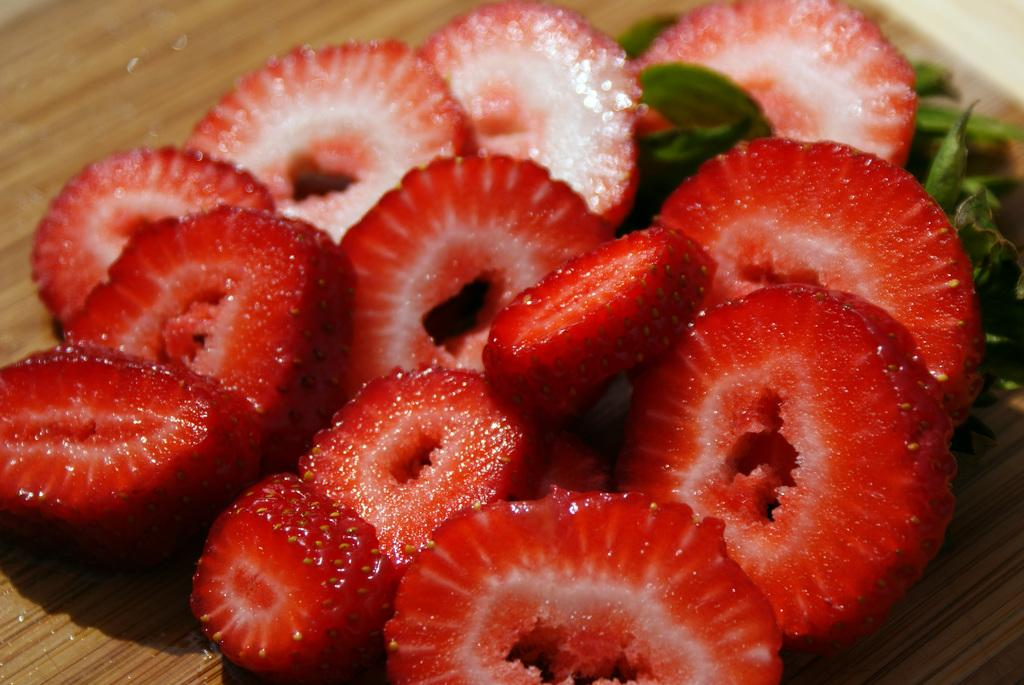What type of fruit is present in the image? There are strawberry pieces in the image. What else can be seen in the image besides the fruit? There are leaves visible in the image. What type of surface is the fruit and leaves placed on? The wooden surface is visible in the image. What color is the bun in the image? There is no bun present in the image. 